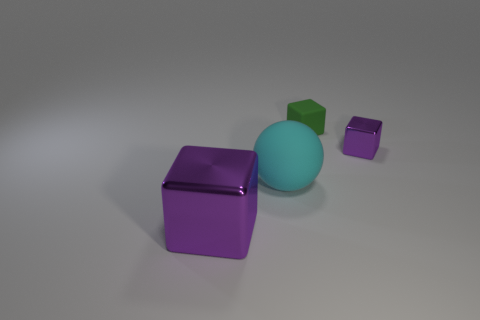Subtract all rubber blocks. How many blocks are left? 2 Add 2 purple objects. How many objects exist? 6 Subtract all purple balls. How many purple cubes are left? 2 Subtract all green blocks. How many blocks are left? 2 Subtract 1 cubes. How many cubes are left? 2 Subtract all spheres. How many objects are left? 3 Add 1 cyan matte spheres. How many cyan matte spheres are left? 2 Add 4 small blue metal balls. How many small blue metal balls exist? 4 Subtract 0 blue cubes. How many objects are left? 4 Subtract all purple spheres. Subtract all green cylinders. How many spheres are left? 1 